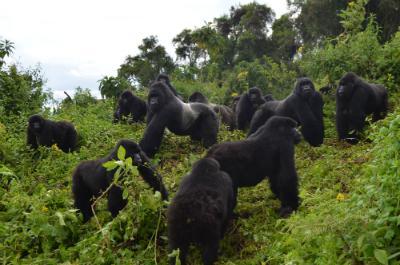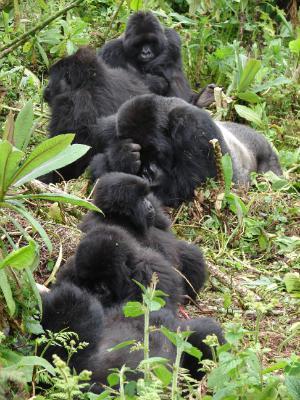The first image is the image on the left, the second image is the image on the right. Given the left and right images, does the statement "There are at most 4 gorillas in one of the images." hold true? Answer yes or no. No. 